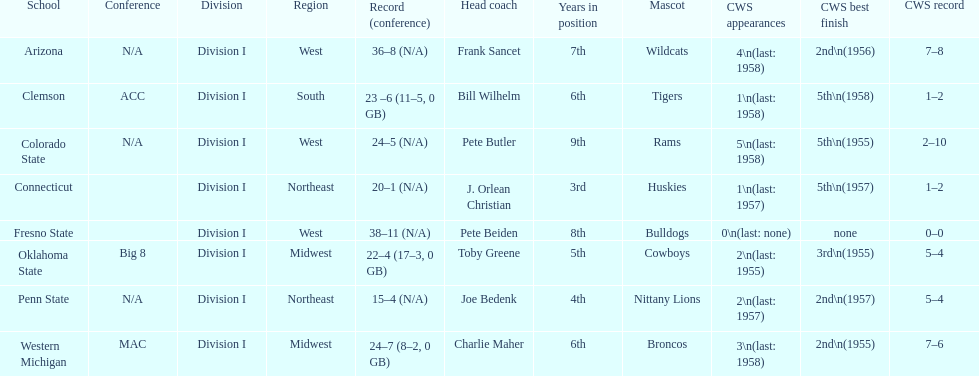Which was the only team with less than 20 wins? Penn State. 